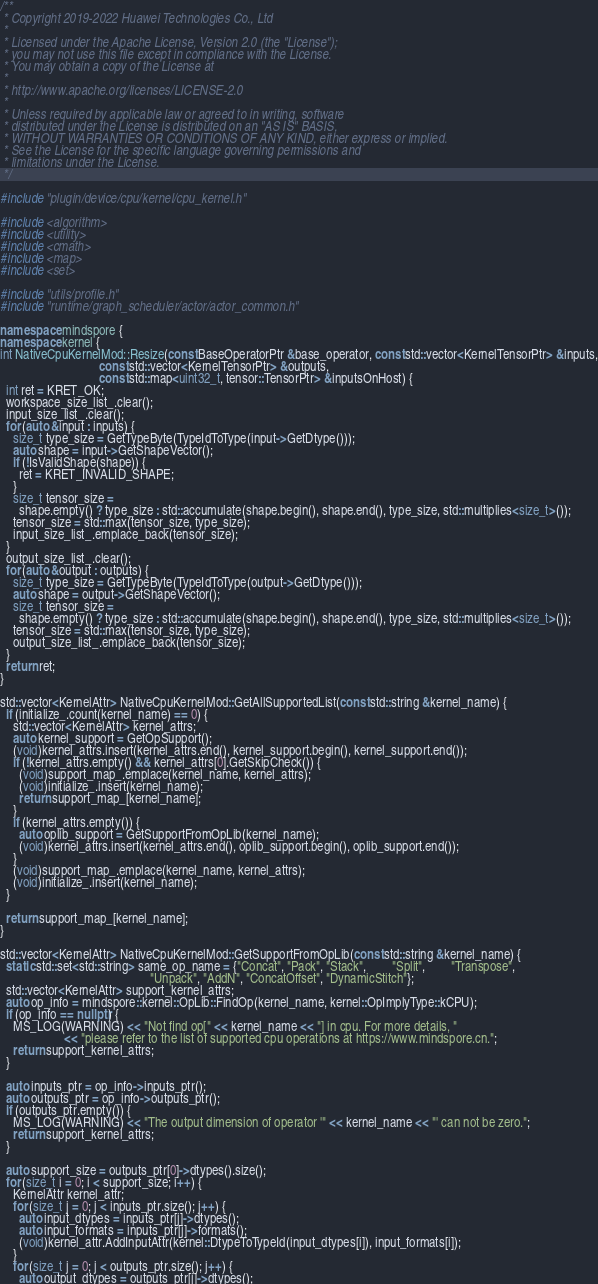<code> <loc_0><loc_0><loc_500><loc_500><_C++_>/**
 * Copyright 2019-2022 Huawei Technologies Co., Ltd
 *
 * Licensed under the Apache License, Version 2.0 (the "License");
 * you may not use this file except in compliance with the License.
 * You may obtain a copy of the License at
 *
 * http://www.apache.org/licenses/LICENSE-2.0
 *
 * Unless required by applicable law or agreed to in writing, software
 * distributed under the License is distributed on an "AS IS" BASIS,
 * WITHOUT WARRANTIES OR CONDITIONS OF ANY KIND, either express or implied.
 * See the License for the specific language governing permissions and
 * limitations under the License.
 */

#include "plugin/device/cpu/kernel/cpu_kernel.h"

#include <algorithm>
#include <utility>
#include <cmath>
#include <map>
#include <set>

#include "utils/profile.h"
#include "runtime/graph_scheduler/actor/actor_common.h"

namespace mindspore {
namespace kernel {
int NativeCpuKernelMod::Resize(const BaseOperatorPtr &base_operator, const std::vector<KernelTensorPtr> &inputs,
                               const std::vector<KernelTensorPtr> &outputs,
                               const std::map<uint32_t, tensor::TensorPtr> &inputsOnHost) {
  int ret = KRET_OK;
  workspace_size_list_.clear();
  input_size_list_.clear();
  for (auto &input : inputs) {
    size_t type_size = GetTypeByte(TypeIdToType(input->GetDtype()));
    auto shape = input->GetShapeVector();
    if (!IsValidShape(shape)) {
      ret = KRET_INVALID_SHAPE;
    }
    size_t tensor_size =
      shape.empty() ? type_size : std::accumulate(shape.begin(), shape.end(), type_size, std::multiplies<size_t>());
    tensor_size = std::max(tensor_size, type_size);
    input_size_list_.emplace_back(tensor_size);
  }
  output_size_list_.clear();
  for (auto &output : outputs) {
    size_t type_size = GetTypeByte(TypeIdToType(output->GetDtype()));
    auto shape = output->GetShapeVector();
    size_t tensor_size =
      shape.empty() ? type_size : std::accumulate(shape.begin(), shape.end(), type_size, std::multiplies<size_t>());
    tensor_size = std::max(tensor_size, type_size);
    output_size_list_.emplace_back(tensor_size);
  }
  return ret;
}

std::vector<KernelAttr> NativeCpuKernelMod::GetAllSupportedList(const std::string &kernel_name) {
  if (initialize_.count(kernel_name) == 0) {
    std::vector<KernelAttr> kernel_attrs;
    auto kernel_support = GetOpSupport();
    (void)kernel_attrs.insert(kernel_attrs.end(), kernel_support.begin(), kernel_support.end());
    if (!kernel_attrs.empty() && kernel_attrs[0].GetSkipCheck()) {
      (void)support_map_.emplace(kernel_name, kernel_attrs);
      (void)initialize_.insert(kernel_name);
      return support_map_[kernel_name];
    }
    if (kernel_attrs.empty()) {
      auto oplib_support = GetSupportFromOpLib(kernel_name);
      (void)kernel_attrs.insert(kernel_attrs.end(), oplib_support.begin(), oplib_support.end());
    }
    (void)support_map_.emplace(kernel_name, kernel_attrs);
    (void)initialize_.insert(kernel_name);
  }

  return support_map_[kernel_name];
}

std::vector<KernelAttr> NativeCpuKernelMod::GetSupportFromOpLib(const std::string &kernel_name) {
  static std::set<std::string> same_op_name = {"Concat", "Pack", "Stack",        "Split",        "Transpose",
                                               "Unpack", "AddN", "ConcatOffset", "DynamicStitch"};
  std::vector<KernelAttr> support_kernel_attrs;
  auto op_info = mindspore::kernel::OpLib::FindOp(kernel_name, kernel::OpImplyType::kCPU);
  if (op_info == nullptr) {
    MS_LOG(WARNING) << "Not find op[" << kernel_name << "] in cpu. For more details, "
                    << "please refer to the list of supported cpu operations at https://www.mindspore.cn.";
    return support_kernel_attrs;
  }

  auto inputs_ptr = op_info->inputs_ptr();
  auto outputs_ptr = op_info->outputs_ptr();
  if (outputs_ptr.empty()) {
    MS_LOG(WARNING) << "The output dimension of operator '" << kernel_name << "' can not be zero.";
    return support_kernel_attrs;
  }

  auto support_size = outputs_ptr[0]->dtypes().size();
  for (size_t i = 0; i < support_size; i++) {
    KernelAttr kernel_attr;
    for (size_t j = 0; j < inputs_ptr.size(); j++) {
      auto input_dtypes = inputs_ptr[j]->dtypes();
      auto input_formats = inputs_ptr[j]->formats();
      (void)kernel_attr.AddInputAttr(kernel::DtypeToTypeId(input_dtypes[i]), input_formats[i]);
    }
    for (size_t j = 0; j < outputs_ptr.size(); j++) {
      auto output_dtypes = outputs_ptr[j]->dtypes();</code> 